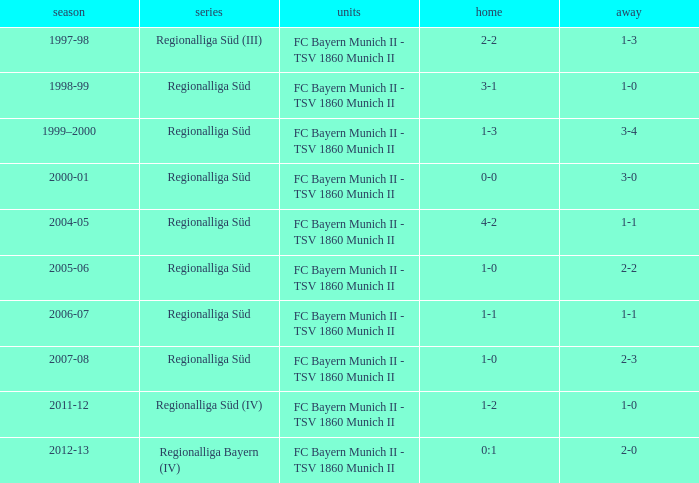Which teams were in the 2006-07 season? FC Bayern Munich II - TSV 1860 Munich II. 